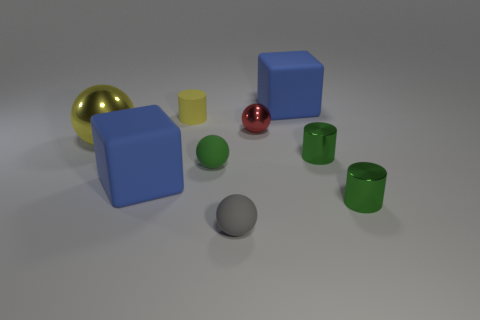Add 1 big balls. How many objects exist? 10 Subtract all balls. How many objects are left? 5 Add 4 large matte cubes. How many large matte cubes exist? 6 Subtract 0 cyan balls. How many objects are left? 9 Subtract all big gray metallic blocks. Subtract all cubes. How many objects are left? 7 Add 6 tiny balls. How many tiny balls are left? 9 